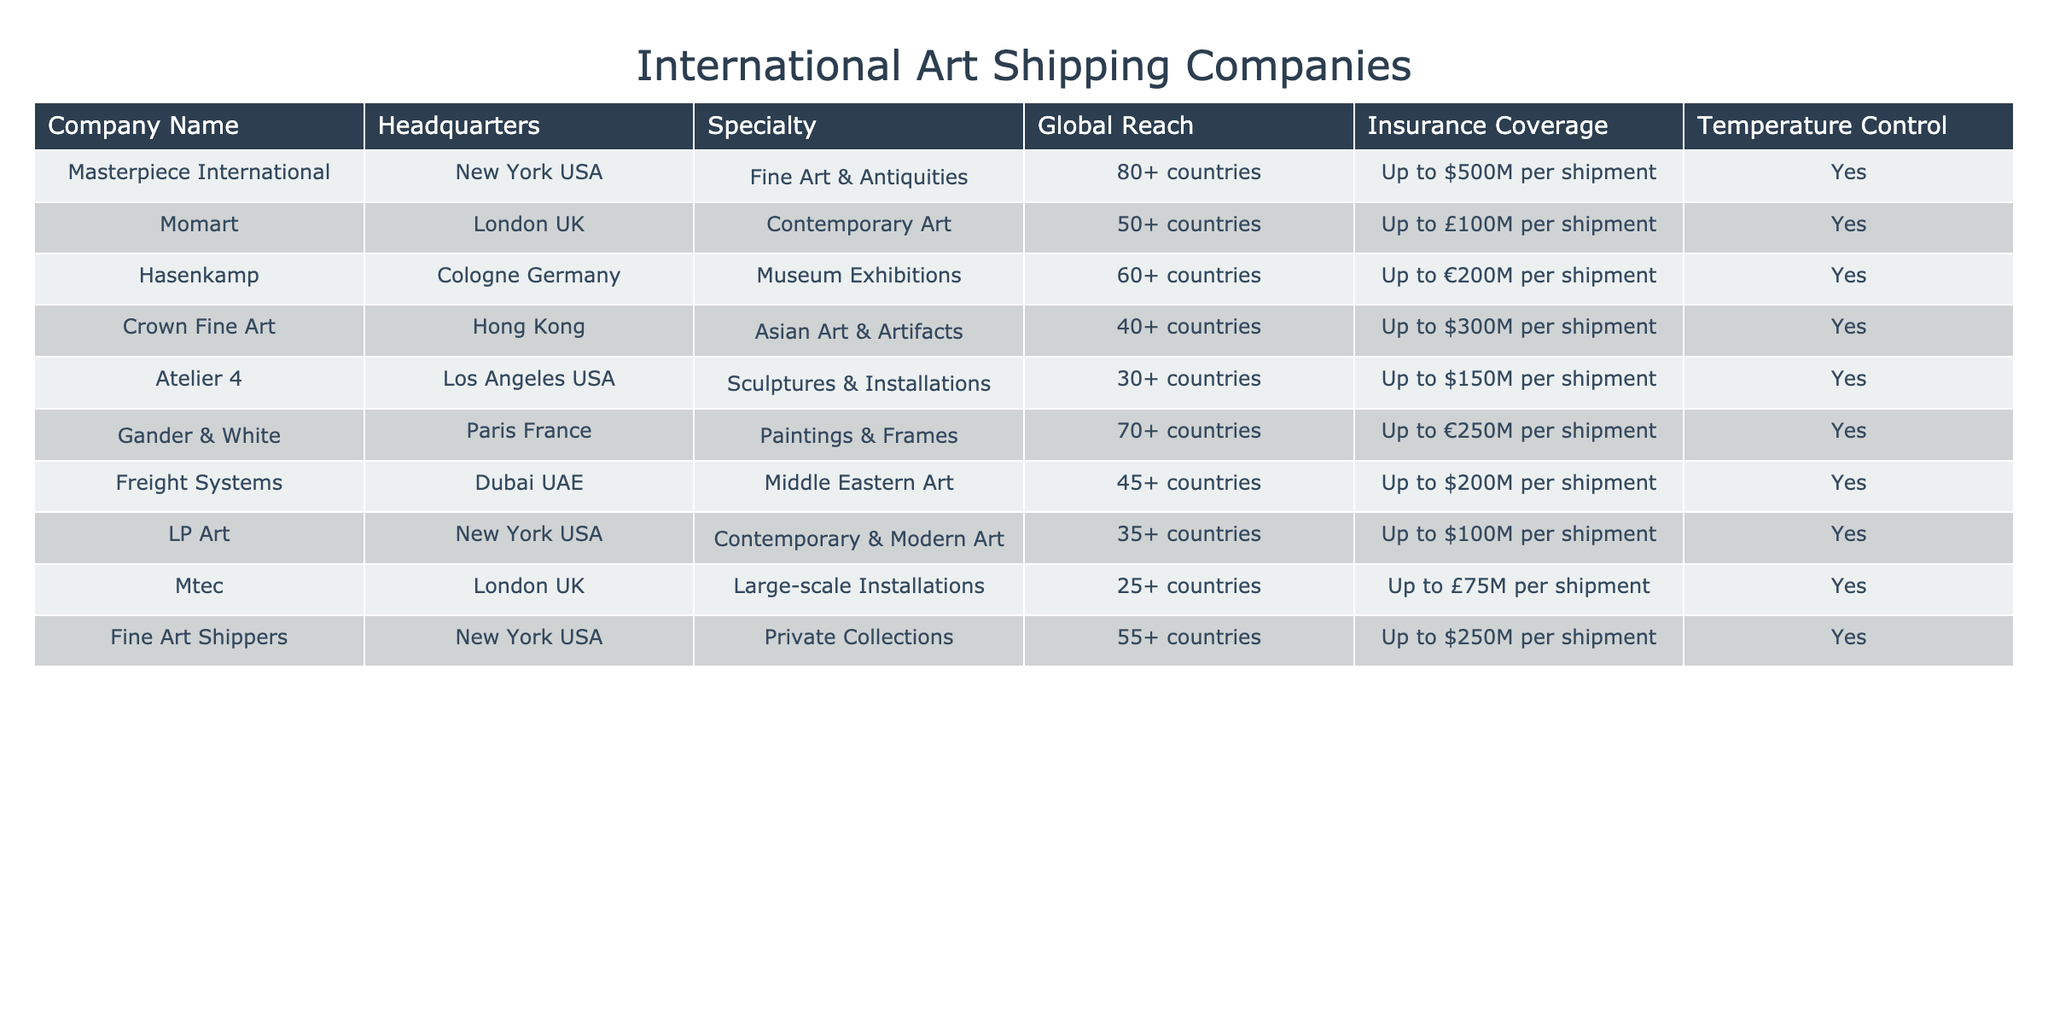What is the headquarters location of Masterpiece International? The table lists "New York USA" as the headquarters for Masterpiece International.
Answer: New York USA Which company specializes in museum exhibitions? The table shows that Hasenkamp specializes in museum exhibitions.
Answer: Hasenkamp How many countries does Crown Fine Art operate in? Crown Fine Art operates in 40+ countries, as indicated in the global reach column.
Answer: 40+ countries Which company provides insurance coverage up to $100 million per shipment? The table reveals that both Momart and LP Art provide insurance coverage up to $100 million per shipment.
Answer: Momart and LP Art What is the maximum insurance coverage provided by Gander & White? The maximum insurance coverage provided by Gander & White is up to €250 million per shipment, as shown in the table.
Answer: Up to €250 million Which company has the least global reach? Atelier 4 operates in 30+ countries, which is less than the other companies listed in the table.
Answer: Atelier 4 What is the total insurance coverage capacity for Fine Art Shippers and Freight Systems? Fine Art Shippers covers up to $250 million, and Freight Systems covers up to $200 million. Summing these gives $250M + $200M = $450M.
Answer: $450 million Is temperature control offered by all companies on the list? Yes, every company in the table offers temperature control, which can be verified from the corresponding column.
Answer: Yes Which company specializes in large-scale installations, and what is its headquarters? The company that specializes in large-scale installations is Mtec, which is headquartered in London UK.
Answer: Mtec, London UK Which company operates in the highest number of countries? Masterpiece International operates in 80+ countries, making it the company with the highest global reach on the list.
Answer: Masterpiece International 